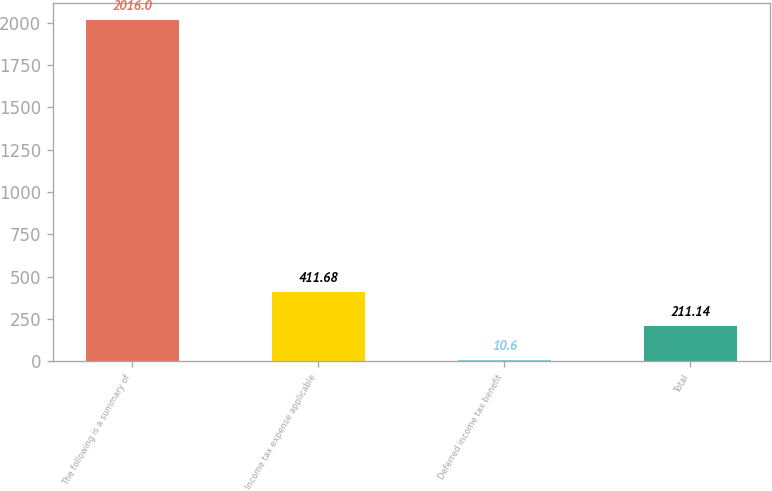Convert chart to OTSL. <chart><loc_0><loc_0><loc_500><loc_500><bar_chart><fcel>The following is a summary of<fcel>Income tax expense applicable<fcel>Deferred income tax benefit<fcel>Total<nl><fcel>2016<fcel>411.68<fcel>10.6<fcel>211.14<nl></chart> 